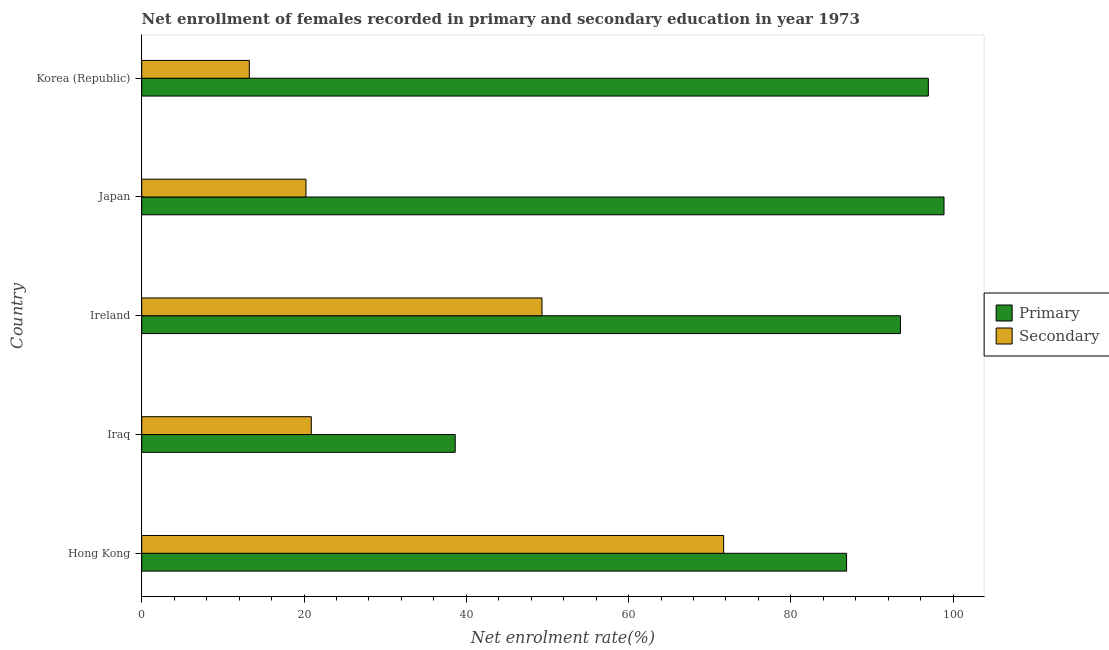How many groups of bars are there?
Your response must be concise. 5. Are the number of bars per tick equal to the number of legend labels?
Your response must be concise. Yes. What is the label of the 1st group of bars from the top?
Offer a very short reply. Korea (Republic). In how many cases, is the number of bars for a given country not equal to the number of legend labels?
Make the answer very short. 0. What is the enrollment rate in secondary education in Ireland?
Ensure brevity in your answer.  49.33. Across all countries, what is the maximum enrollment rate in secondary education?
Your answer should be compact. 71.72. Across all countries, what is the minimum enrollment rate in secondary education?
Provide a short and direct response. 13.26. In which country was the enrollment rate in secondary education maximum?
Your response must be concise. Hong Kong. What is the total enrollment rate in primary education in the graph?
Provide a short and direct response. 414.84. What is the difference between the enrollment rate in secondary education in Iraq and that in Korea (Republic)?
Make the answer very short. 7.64. What is the difference between the enrollment rate in primary education in Korea (Republic) and the enrollment rate in secondary education in Iraq?
Your response must be concise. 76.05. What is the average enrollment rate in secondary education per country?
Keep it short and to the point. 35.09. What is the difference between the enrollment rate in primary education and enrollment rate in secondary education in Hong Kong?
Ensure brevity in your answer.  15.15. In how many countries, is the enrollment rate in secondary education greater than 80 %?
Your answer should be compact. 0. What is the ratio of the enrollment rate in secondary education in Iraq to that in Korea (Republic)?
Offer a very short reply. 1.58. Is the enrollment rate in secondary education in Hong Kong less than that in Japan?
Your answer should be compact. No. What is the difference between the highest and the second highest enrollment rate in primary education?
Provide a succinct answer. 1.93. What is the difference between the highest and the lowest enrollment rate in primary education?
Provide a short and direct response. 60.24. In how many countries, is the enrollment rate in secondary education greater than the average enrollment rate in secondary education taken over all countries?
Give a very brief answer. 2. Is the sum of the enrollment rate in secondary education in Iraq and Japan greater than the maximum enrollment rate in primary education across all countries?
Offer a terse response. No. What does the 2nd bar from the top in Hong Kong represents?
Provide a short and direct response. Primary. What does the 2nd bar from the bottom in Hong Kong represents?
Ensure brevity in your answer.  Secondary. Are all the bars in the graph horizontal?
Keep it short and to the point. Yes. How many legend labels are there?
Give a very brief answer. 2. What is the title of the graph?
Give a very brief answer. Net enrollment of females recorded in primary and secondary education in year 1973. Does "Secondary school" appear as one of the legend labels in the graph?
Give a very brief answer. No. What is the label or title of the X-axis?
Keep it short and to the point. Net enrolment rate(%). What is the Net enrolment rate(%) in Primary in Hong Kong?
Your answer should be compact. 86.87. What is the Net enrolment rate(%) of Secondary in Hong Kong?
Make the answer very short. 71.72. What is the Net enrolment rate(%) in Primary in Iraq?
Keep it short and to the point. 38.64. What is the Net enrolment rate(%) in Secondary in Iraq?
Your answer should be compact. 20.9. What is the Net enrolment rate(%) of Primary in Ireland?
Your response must be concise. 93.51. What is the Net enrolment rate(%) in Secondary in Ireland?
Offer a terse response. 49.33. What is the Net enrolment rate(%) in Primary in Japan?
Your response must be concise. 98.88. What is the Net enrolment rate(%) in Secondary in Japan?
Offer a terse response. 20.24. What is the Net enrolment rate(%) in Primary in Korea (Republic)?
Provide a succinct answer. 96.95. What is the Net enrolment rate(%) in Secondary in Korea (Republic)?
Give a very brief answer. 13.26. Across all countries, what is the maximum Net enrolment rate(%) in Primary?
Your answer should be compact. 98.88. Across all countries, what is the maximum Net enrolment rate(%) of Secondary?
Provide a short and direct response. 71.72. Across all countries, what is the minimum Net enrolment rate(%) in Primary?
Your answer should be compact. 38.64. Across all countries, what is the minimum Net enrolment rate(%) in Secondary?
Offer a very short reply. 13.26. What is the total Net enrolment rate(%) of Primary in the graph?
Offer a very short reply. 414.84. What is the total Net enrolment rate(%) in Secondary in the graph?
Provide a succinct answer. 175.45. What is the difference between the Net enrolment rate(%) in Primary in Hong Kong and that in Iraq?
Your response must be concise. 48.24. What is the difference between the Net enrolment rate(%) of Secondary in Hong Kong and that in Iraq?
Your answer should be very brief. 50.82. What is the difference between the Net enrolment rate(%) of Primary in Hong Kong and that in Ireland?
Offer a terse response. -6.64. What is the difference between the Net enrolment rate(%) of Secondary in Hong Kong and that in Ireland?
Keep it short and to the point. 22.39. What is the difference between the Net enrolment rate(%) in Primary in Hong Kong and that in Japan?
Your response must be concise. -12.01. What is the difference between the Net enrolment rate(%) in Secondary in Hong Kong and that in Japan?
Your answer should be very brief. 51.48. What is the difference between the Net enrolment rate(%) in Primary in Hong Kong and that in Korea (Republic)?
Provide a succinct answer. -10.08. What is the difference between the Net enrolment rate(%) in Secondary in Hong Kong and that in Korea (Republic)?
Offer a very short reply. 58.46. What is the difference between the Net enrolment rate(%) in Primary in Iraq and that in Ireland?
Ensure brevity in your answer.  -54.88. What is the difference between the Net enrolment rate(%) in Secondary in Iraq and that in Ireland?
Give a very brief answer. -28.43. What is the difference between the Net enrolment rate(%) in Primary in Iraq and that in Japan?
Your answer should be very brief. -60.24. What is the difference between the Net enrolment rate(%) of Secondary in Iraq and that in Japan?
Make the answer very short. 0.65. What is the difference between the Net enrolment rate(%) in Primary in Iraq and that in Korea (Republic)?
Make the answer very short. -58.31. What is the difference between the Net enrolment rate(%) of Secondary in Iraq and that in Korea (Republic)?
Make the answer very short. 7.64. What is the difference between the Net enrolment rate(%) in Primary in Ireland and that in Japan?
Provide a short and direct response. -5.37. What is the difference between the Net enrolment rate(%) in Secondary in Ireland and that in Japan?
Make the answer very short. 29.09. What is the difference between the Net enrolment rate(%) of Primary in Ireland and that in Korea (Republic)?
Offer a terse response. -3.44. What is the difference between the Net enrolment rate(%) of Secondary in Ireland and that in Korea (Republic)?
Make the answer very short. 36.07. What is the difference between the Net enrolment rate(%) of Primary in Japan and that in Korea (Republic)?
Your answer should be compact. 1.93. What is the difference between the Net enrolment rate(%) in Secondary in Japan and that in Korea (Republic)?
Offer a very short reply. 6.98. What is the difference between the Net enrolment rate(%) of Primary in Hong Kong and the Net enrolment rate(%) of Secondary in Iraq?
Give a very brief answer. 65.97. What is the difference between the Net enrolment rate(%) in Primary in Hong Kong and the Net enrolment rate(%) in Secondary in Ireland?
Keep it short and to the point. 37.54. What is the difference between the Net enrolment rate(%) in Primary in Hong Kong and the Net enrolment rate(%) in Secondary in Japan?
Your answer should be compact. 66.63. What is the difference between the Net enrolment rate(%) of Primary in Hong Kong and the Net enrolment rate(%) of Secondary in Korea (Republic)?
Your answer should be very brief. 73.61. What is the difference between the Net enrolment rate(%) of Primary in Iraq and the Net enrolment rate(%) of Secondary in Ireland?
Keep it short and to the point. -10.7. What is the difference between the Net enrolment rate(%) of Primary in Iraq and the Net enrolment rate(%) of Secondary in Japan?
Give a very brief answer. 18.39. What is the difference between the Net enrolment rate(%) in Primary in Iraq and the Net enrolment rate(%) in Secondary in Korea (Republic)?
Keep it short and to the point. 25.37. What is the difference between the Net enrolment rate(%) of Primary in Ireland and the Net enrolment rate(%) of Secondary in Japan?
Give a very brief answer. 73.27. What is the difference between the Net enrolment rate(%) of Primary in Ireland and the Net enrolment rate(%) of Secondary in Korea (Republic)?
Your response must be concise. 80.25. What is the difference between the Net enrolment rate(%) of Primary in Japan and the Net enrolment rate(%) of Secondary in Korea (Republic)?
Offer a terse response. 85.62. What is the average Net enrolment rate(%) in Primary per country?
Make the answer very short. 82.97. What is the average Net enrolment rate(%) in Secondary per country?
Offer a terse response. 35.09. What is the difference between the Net enrolment rate(%) of Primary and Net enrolment rate(%) of Secondary in Hong Kong?
Offer a very short reply. 15.15. What is the difference between the Net enrolment rate(%) in Primary and Net enrolment rate(%) in Secondary in Iraq?
Provide a short and direct response. 17.74. What is the difference between the Net enrolment rate(%) in Primary and Net enrolment rate(%) in Secondary in Ireland?
Give a very brief answer. 44.18. What is the difference between the Net enrolment rate(%) of Primary and Net enrolment rate(%) of Secondary in Japan?
Your answer should be compact. 78.64. What is the difference between the Net enrolment rate(%) of Primary and Net enrolment rate(%) of Secondary in Korea (Republic)?
Make the answer very short. 83.69. What is the ratio of the Net enrolment rate(%) in Primary in Hong Kong to that in Iraq?
Give a very brief answer. 2.25. What is the ratio of the Net enrolment rate(%) of Secondary in Hong Kong to that in Iraq?
Your answer should be very brief. 3.43. What is the ratio of the Net enrolment rate(%) of Primary in Hong Kong to that in Ireland?
Provide a succinct answer. 0.93. What is the ratio of the Net enrolment rate(%) of Secondary in Hong Kong to that in Ireland?
Give a very brief answer. 1.45. What is the ratio of the Net enrolment rate(%) in Primary in Hong Kong to that in Japan?
Provide a short and direct response. 0.88. What is the ratio of the Net enrolment rate(%) in Secondary in Hong Kong to that in Japan?
Provide a short and direct response. 3.54. What is the ratio of the Net enrolment rate(%) in Primary in Hong Kong to that in Korea (Republic)?
Your response must be concise. 0.9. What is the ratio of the Net enrolment rate(%) of Secondary in Hong Kong to that in Korea (Republic)?
Make the answer very short. 5.41. What is the ratio of the Net enrolment rate(%) of Primary in Iraq to that in Ireland?
Your answer should be compact. 0.41. What is the ratio of the Net enrolment rate(%) of Secondary in Iraq to that in Ireland?
Your answer should be compact. 0.42. What is the ratio of the Net enrolment rate(%) of Primary in Iraq to that in Japan?
Offer a very short reply. 0.39. What is the ratio of the Net enrolment rate(%) of Secondary in Iraq to that in Japan?
Keep it short and to the point. 1.03. What is the ratio of the Net enrolment rate(%) of Primary in Iraq to that in Korea (Republic)?
Give a very brief answer. 0.4. What is the ratio of the Net enrolment rate(%) of Secondary in Iraq to that in Korea (Republic)?
Offer a terse response. 1.58. What is the ratio of the Net enrolment rate(%) of Primary in Ireland to that in Japan?
Provide a succinct answer. 0.95. What is the ratio of the Net enrolment rate(%) of Secondary in Ireland to that in Japan?
Offer a very short reply. 2.44. What is the ratio of the Net enrolment rate(%) in Primary in Ireland to that in Korea (Republic)?
Your answer should be very brief. 0.96. What is the ratio of the Net enrolment rate(%) of Secondary in Ireland to that in Korea (Republic)?
Your response must be concise. 3.72. What is the ratio of the Net enrolment rate(%) in Primary in Japan to that in Korea (Republic)?
Give a very brief answer. 1.02. What is the ratio of the Net enrolment rate(%) of Secondary in Japan to that in Korea (Republic)?
Your response must be concise. 1.53. What is the difference between the highest and the second highest Net enrolment rate(%) of Primary?
Offer a terse response. 1.93. What is the difference between the highest and the second highest Net enrolment rate(%) in Secondary?
Give a very brief answer. 22.39. What is the difference between the highest and the lowest Net enrolment rate(%) in Primary?
Ensure brevity in your answer.  60.24. What is the difference between the highest and the lowest Net enrolment rate(%) of Secondary?
Provide a succinct answer. 58.46. 